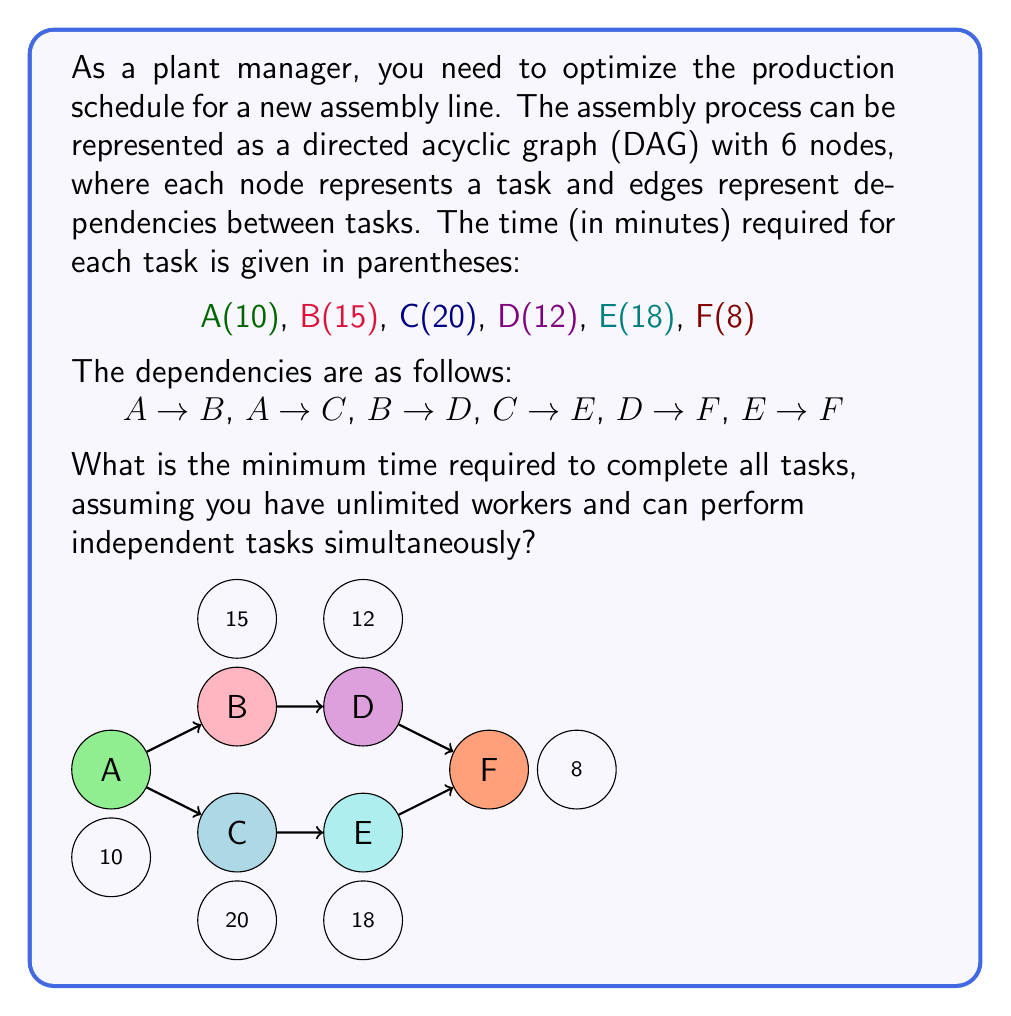Teach me how to tackle this problem. To solve this problem, we need to find the critical path in the directed acyclic graph (DAG) representing the assembly process. The critical path is the longest path from the start to the end of the project, which determines the minimum time required to complete all tasks.

Let's solve this step-by-step:

1) First, we need to calculate the earliest start time (EST) for each task:

   A: EST(A) = 0 (start of the project)
   B: EST(B) = EST(A) + Time(A) = 0 + 10 = 10
   C: EST(C) = EST(A) + Time(A) = 0 + 10 = 10
   D: EST(D) = EST(B) + Time(B) = 10 + 15 = 25
   E: EST(E) = EST(C) + Time(C) = 10 + 20 = 30
   F: EST(F) = max(EST(D) + Time(D), EST(E) + Time(E))
              = max(25 + 12, 30 + 18) = max(37, 48) = 48

2) Now, we calculate the earliest finish time (EFT) for each task:

   EFT = EST + Task Time

   A: EFT(A) = 0 + 10 = 10
   B: EFT(B) = 10 + 15 = 25
   C: EFT(C) = 10 + 20 = 30
   D: EFT(D) = 25 + 12 = 37
   E: EFT(E) = 30 + 18 = 48
   F: EFT(F) = 48 + 8 = 56

3) The minimum time required to complete all tasks is the EFT of the final task, which is task F.

Therefore, the minimum time required to complete all tasks is 56 minutes.

The critical path in this case is A → C → E → F, with a total duration of 10 + 20 + 18 + 8 = 56 minutes.
Answer: The minimum time required to complete all tasks is 56 minutes. 